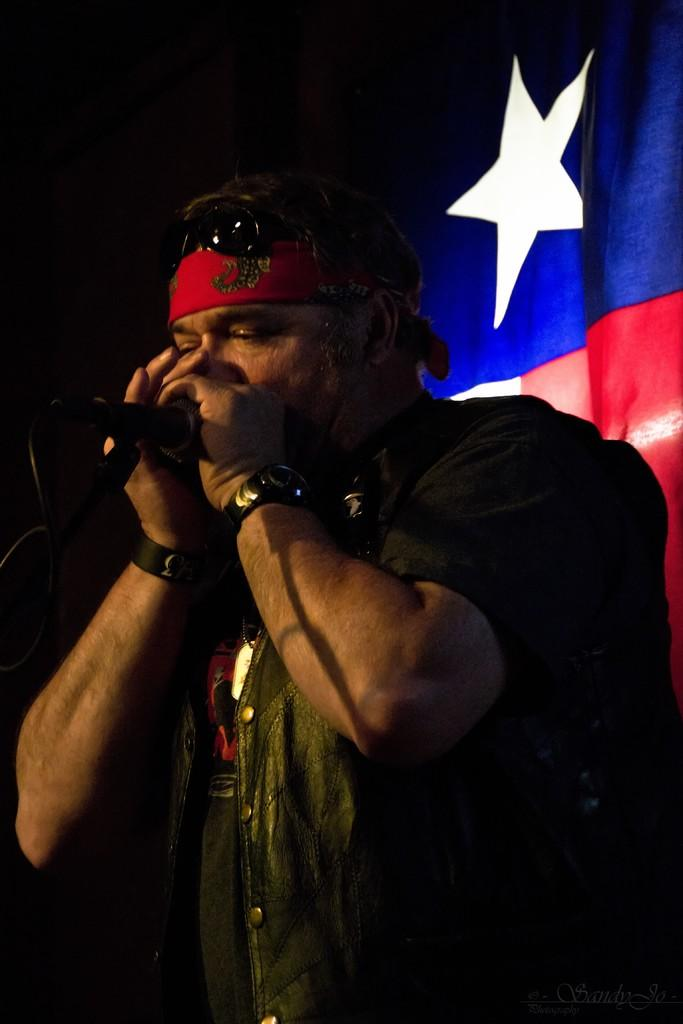What is the person in the image doing? The person is holding a microphone in their hand. What can be seen in the background of the image? There is a curtain in the background of the image. Can you describe the setting of the image? The image may have been taken on a stage during nighttime. How much wealth is displayed on the sofa in the image? There is no sofa or wealth present in the image; it only features a person holding a microphone and a curtain in the background. 